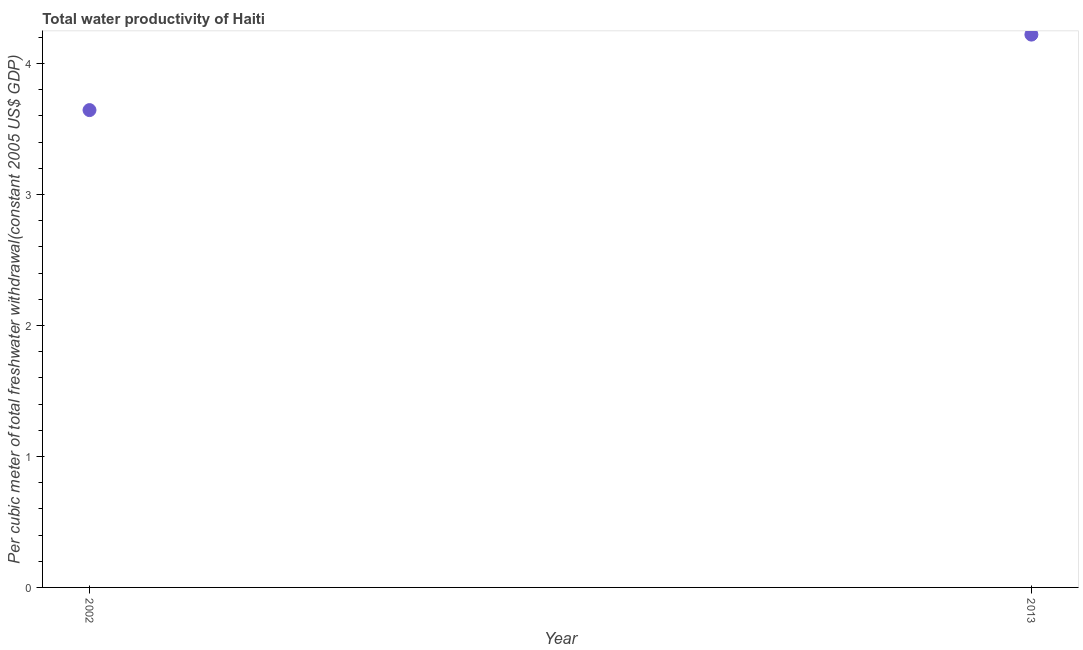What is the total water productivity in 2002?
Keep it short and to the point. 3.64. Across all years, what is the maximum total water productivity?
Offer a very short reply. 4.22. Across all years, what is the minimum total water productivity?
Give a very brief answer. 3.64. What is the sum of the total water productivity?
Your answer should be compact. 7.86. What is the difference between the total water productivity in 2002 and 2013?
Provide a succinct answer. -0.58. What is the average total water productivity per year?
Keep it short and to the point. 3.93. What is the median total water productivity?
Your answer should be very brief. 3.93. In how many years, is the total water productivity greater than 1.2 US$?
Provide a succinct answer. 2. Do a majority of the years between 2013 and 2002 (inclusive) have total water productivity greater than 4 US$?
Keep it short and to the point. No. What is the ratio of the total water productivity in 2002 to that in 2013?
Your answer should be compact. 0.86. Is the total water productivity in 2002 less than that in 2013?
Offer a terse response. Yes. Does the total water productivity monotonically increase over the years?
Provide a succinct answer. Yes. How many years are there in the graph?
Your answer should be very brief. 2. What is the difference between two consecutive major ticks on the Y-axis?
Give a very brief answer. 1. Are the values on the major ticks of Y-axis written in scientific E-notation?
Your answer should be very brief. No. What is the title of the graph?
Offer a terse response. Total water productivity of Haiti. What is the label or title of the Y-axis?
Ensure brevity in your answer.  Per cubic meter of total freshwater withdrawal(constant 2005 US$ GDP). What is the Per cubic meter of total freshwater withdrawal(constant 2005 US$ GDP) in 2002?
Provide a short and direct response. 3.64. What is the Per cubic meter of total freshwater withdrawal(constant 2005 US$ GDP) in 2013?
Provide a succinct answer. 4.22. What is the difference between the Per cubic meter of total freshwater withdrawal(constant 2005 US$ GDP) in 2002 and 2013?
Your response must be concise. -0.58. What is the ratio of the Per cubic meter of total freshwater withdrawal(constant 2005 US$ GDP) in 2002 to that in 2013?
Provide a short and direct response. 0.86. 